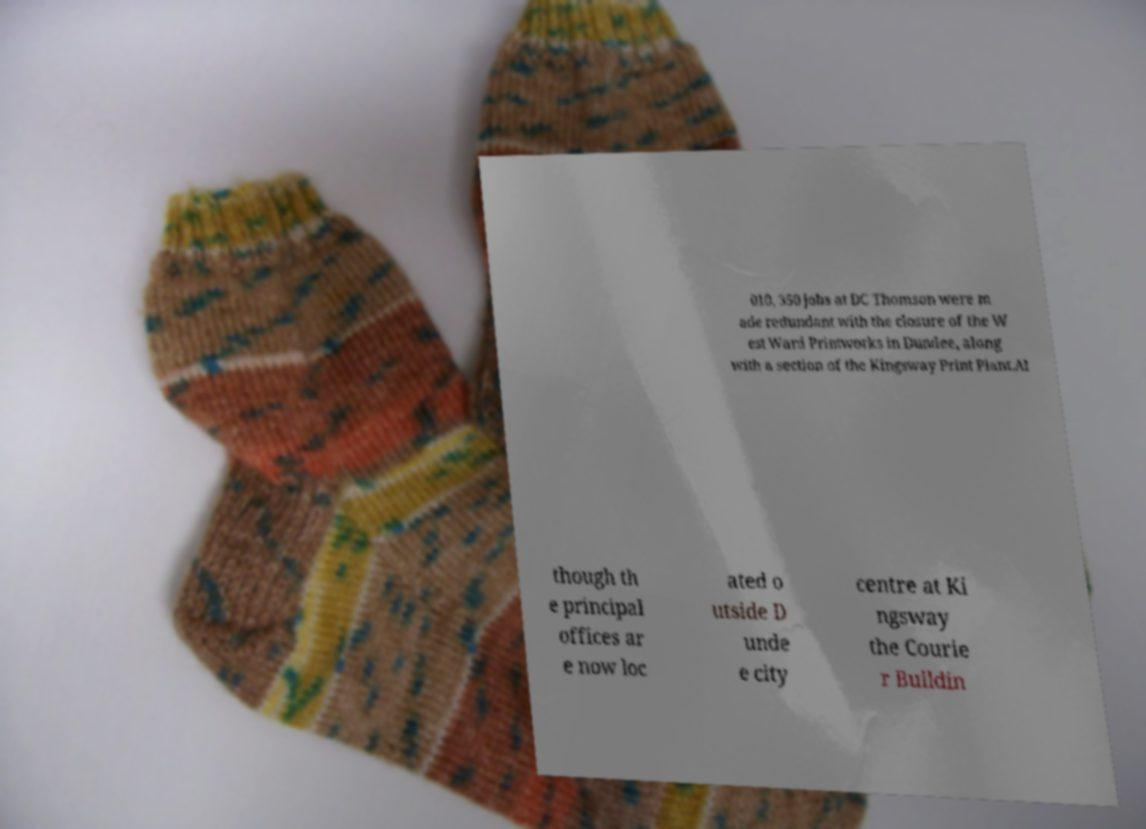Can you read and provide the text displayed in the image?This photo seems to have some interesting text. Can you extract and type it out for me? 010, 350 jobs at DC Thomson were m ade redundant with the closure of the W est Ward Printworks in Dundee, along with a section of the Kingsway Print Plant.Al though th e principal offices ar e now loc ated o utside D unde e city centre at Ki ngsway the Courie r Buildin 